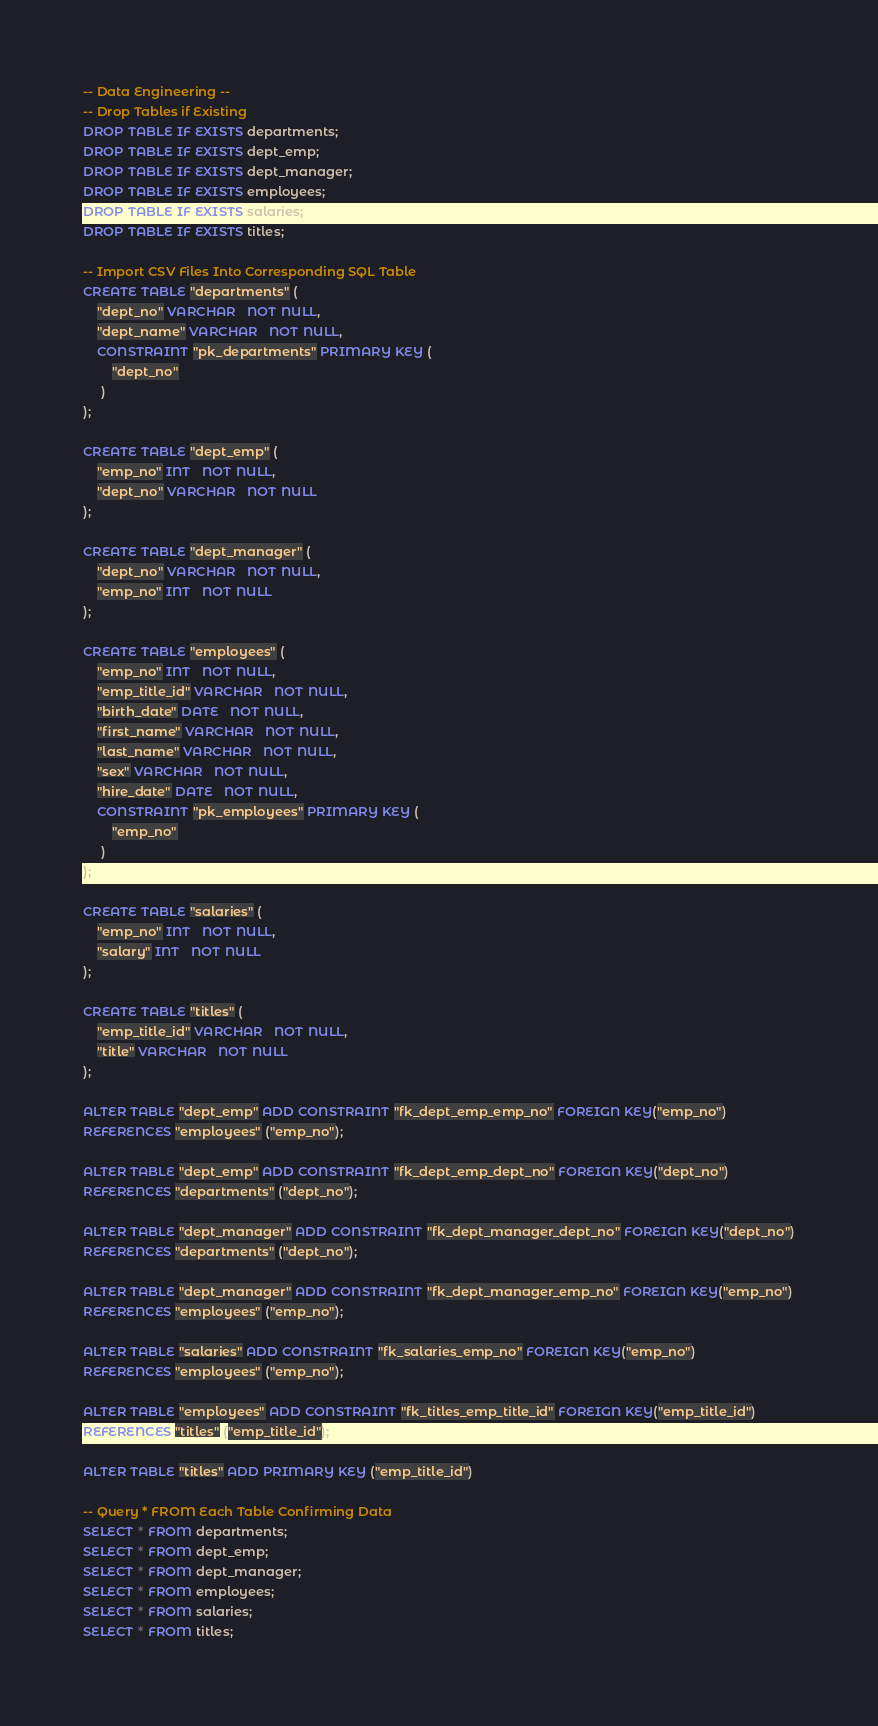Convert code to text. <code><loc_0><loc_0><loc_500><loc_500><_SQL_>-- Data Engineering --
-- Drop Tables if Existing
DROP TABLE IF EXISTS departments;
DROP TABLE IF EXISTS dept_emp;
DROP TABLE IF EXISTS dept_manager;
DROP TABLE IF EXISTS employees;
DROP TABLE IF EXISTS salaries;
DROP TABLE IF EXISTS titles;

-- Import CSV Files Into Corresponding SQL Table
CREATE TABLE "departments" (
    "dept_no" VARCHAR   NOT NULL,
    "dept_name" VARCHAR   NOT NULL,
    CONSTRAINT "pk_departments" PRIMARY KEY (
        "dept_no"
     )
);

CREATE TABLE "dept_emp" (
    "emp_no" INT   NOT NULL,
    "dept_no" VARCHAR   NOT NULL
);

CREATE TABLE "dept_manager" (
    "dept_no" VARCHAR   NOT NULL,
    "emp_no" INT   NOT NULL
);

CREATE TABLE "employees" (
    "emp_no" INT   NOT NULL,
	"emp_title_id" VARCHAR   NOT NULL,
    "birth_date" DATE   NOT NULL,
    "first_name" VARCHAR   NOT NULL,
    "last_name" VARCHAR   NOT NULL,
    "sex" VARCHAR   NOT NULL,
    "hire_date" DATE   NOT NULL,
    CONSTRAINT "pk_employees" PRIMARY KEY (
        "emp_no"
     )
);

CREATE TABLE "salaries" (
    "emp_no" INT   NOT NULL,
    "salary" INT   NOT NULL
);

CREATE TABLE "titles" (
    "emp_title_id" VARCHAR   NOT NULL,
    "title" VARCHAR   NOT NULL
);

ALTER TABLE "dept_emp" ADD CONSTRAINT "fk_dept_emp_emp_no" FOREIGN KEY("emp_no")
REFERENCES "employees" ("emp_no");

ALTER TABLE "dept_emp" ADD CONSTRAINT "fk_dept_emp_dept_no" FOREIGN KEY("dept_no")
REFERENCES "departments" ("dept_no");

ALTER TABLE "dept_manager" ADD CONSTRAINT "fk_dept_manager_dept_no" FOREIGN KEY("dept_no")
REFERENCES "departments" ("dept_no");

ALTER TABLE "dept_manager" ADD CONSTRAINT "fk_dept_manager_emp_no" FOREIGN KEY("emp_no")
REFERENCES "employees" ("emp_no");

ALTER TABLE "salaries" ADD CONSTRAINT "fk_salaries_emp_no" FOREIGN KEY("emp_no")
REFERENCES "employees" ("emp_no");

ALTER TABLE "employees" ADD CONSTRAINT "fk_titles_emp_title_id" FOREIGN KEY("emp_title_id")
REFERENCES "titles" ("emp_title_id");

ALTER TABLE "titles" ADD PRIMARY KEY ("emp_title_id")

-- Query * FROM Each Table Confirming Data
SELECT * FROM departments;
SELECT * FROM dept_emp;
SELECT * FROM dept_manager;
SELECT * FROM employees;
SELECT * FROM salaries;
SELECT * FROM titles;</code> 